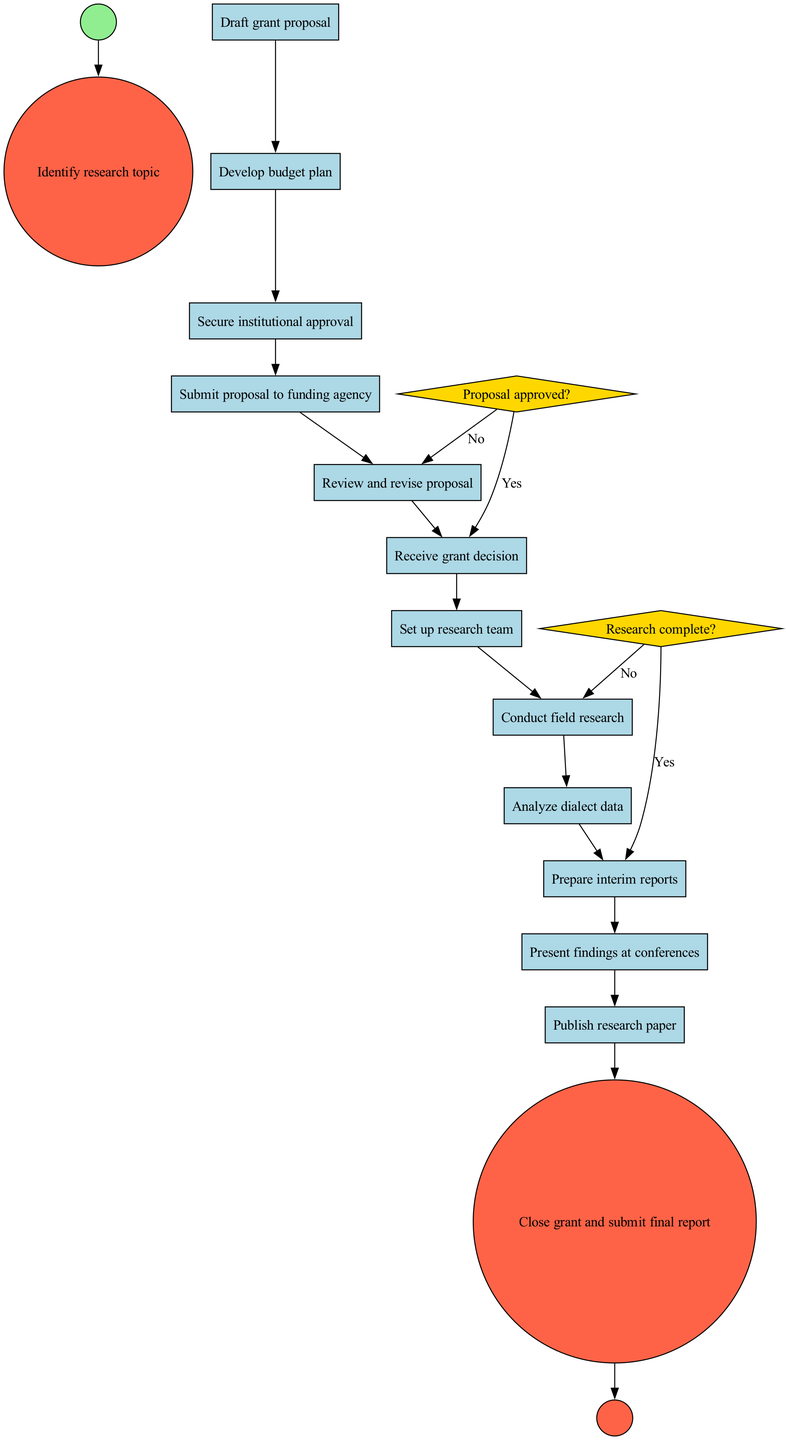What is the first activity in the diagram? The first activity is defined as the one directly connected to the start node, which is "Identify research topic."
Answer: Identify research topic How many activities are listed in the diagram? By counting each item listed under the "activities" section, there are a total of 12 activities described in the diagram.
Answer: 12 What happens if the proposal is not approved? Referring to the decision node "Proposal approved?", if the answer is "No," the flow directs to "Review and revise proposal."
Answer: Review and revise proposal What is the last activity before closing the grant? The final activity noted before reaching the end node is "Publish research paper," which indicates the last step taken after analyzing the dialect data.
Answer: Publish research paper Which decision node relates to the completion of research? The decision node labeled "Research complete?" uniquely addresses the completion status of the research process, indicating whether to prepare reports or conduct further research.
Answer: Research complete? What is the connection between "Submit proposal to funding agency" and "Review and revise proposal"? The pathway between these two nodes illustrates a process bifurcating from "Proposal approved?" where if the proposal is not accepted, it redirects to "Review and revise proposal," indicating a feedback loop in the process.
Answer: Proposal not approved What action follows after receiving a grant decision if approved? If the proposal is affirmed, the next step indicated in the process is "Set up research team," demonstrating the direct forward movement after a successful grant approval.
Answer: Set up research team What is the purpose of the diamond-shaped nodes in this diagram? In activity diagrams, diamond-shaped nodes represent decision points wherein the flow can diverge based on certain conditions, such as whether the proposal is approved or if the research is complete.
Answer: Decision points How many decision nodes are in the diagram? By reviewing the diagram, there are a total of two decision nodes explicitly stated, which are "Proposal approved?" and "Research complete?"
Answer: 2 